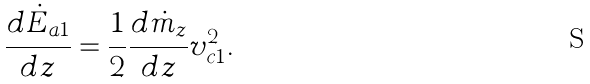Convert formula to latex. <formula><loc_0><loc_0><loc_500><loc_500>\frac { d \dot { E } _ { a 1 } } { d z } = \frac { 1 } { 2 } \frac { d \dot { m } _ { z } } { d z } v _ { c 1 } ^ { 2 } .</formula> 